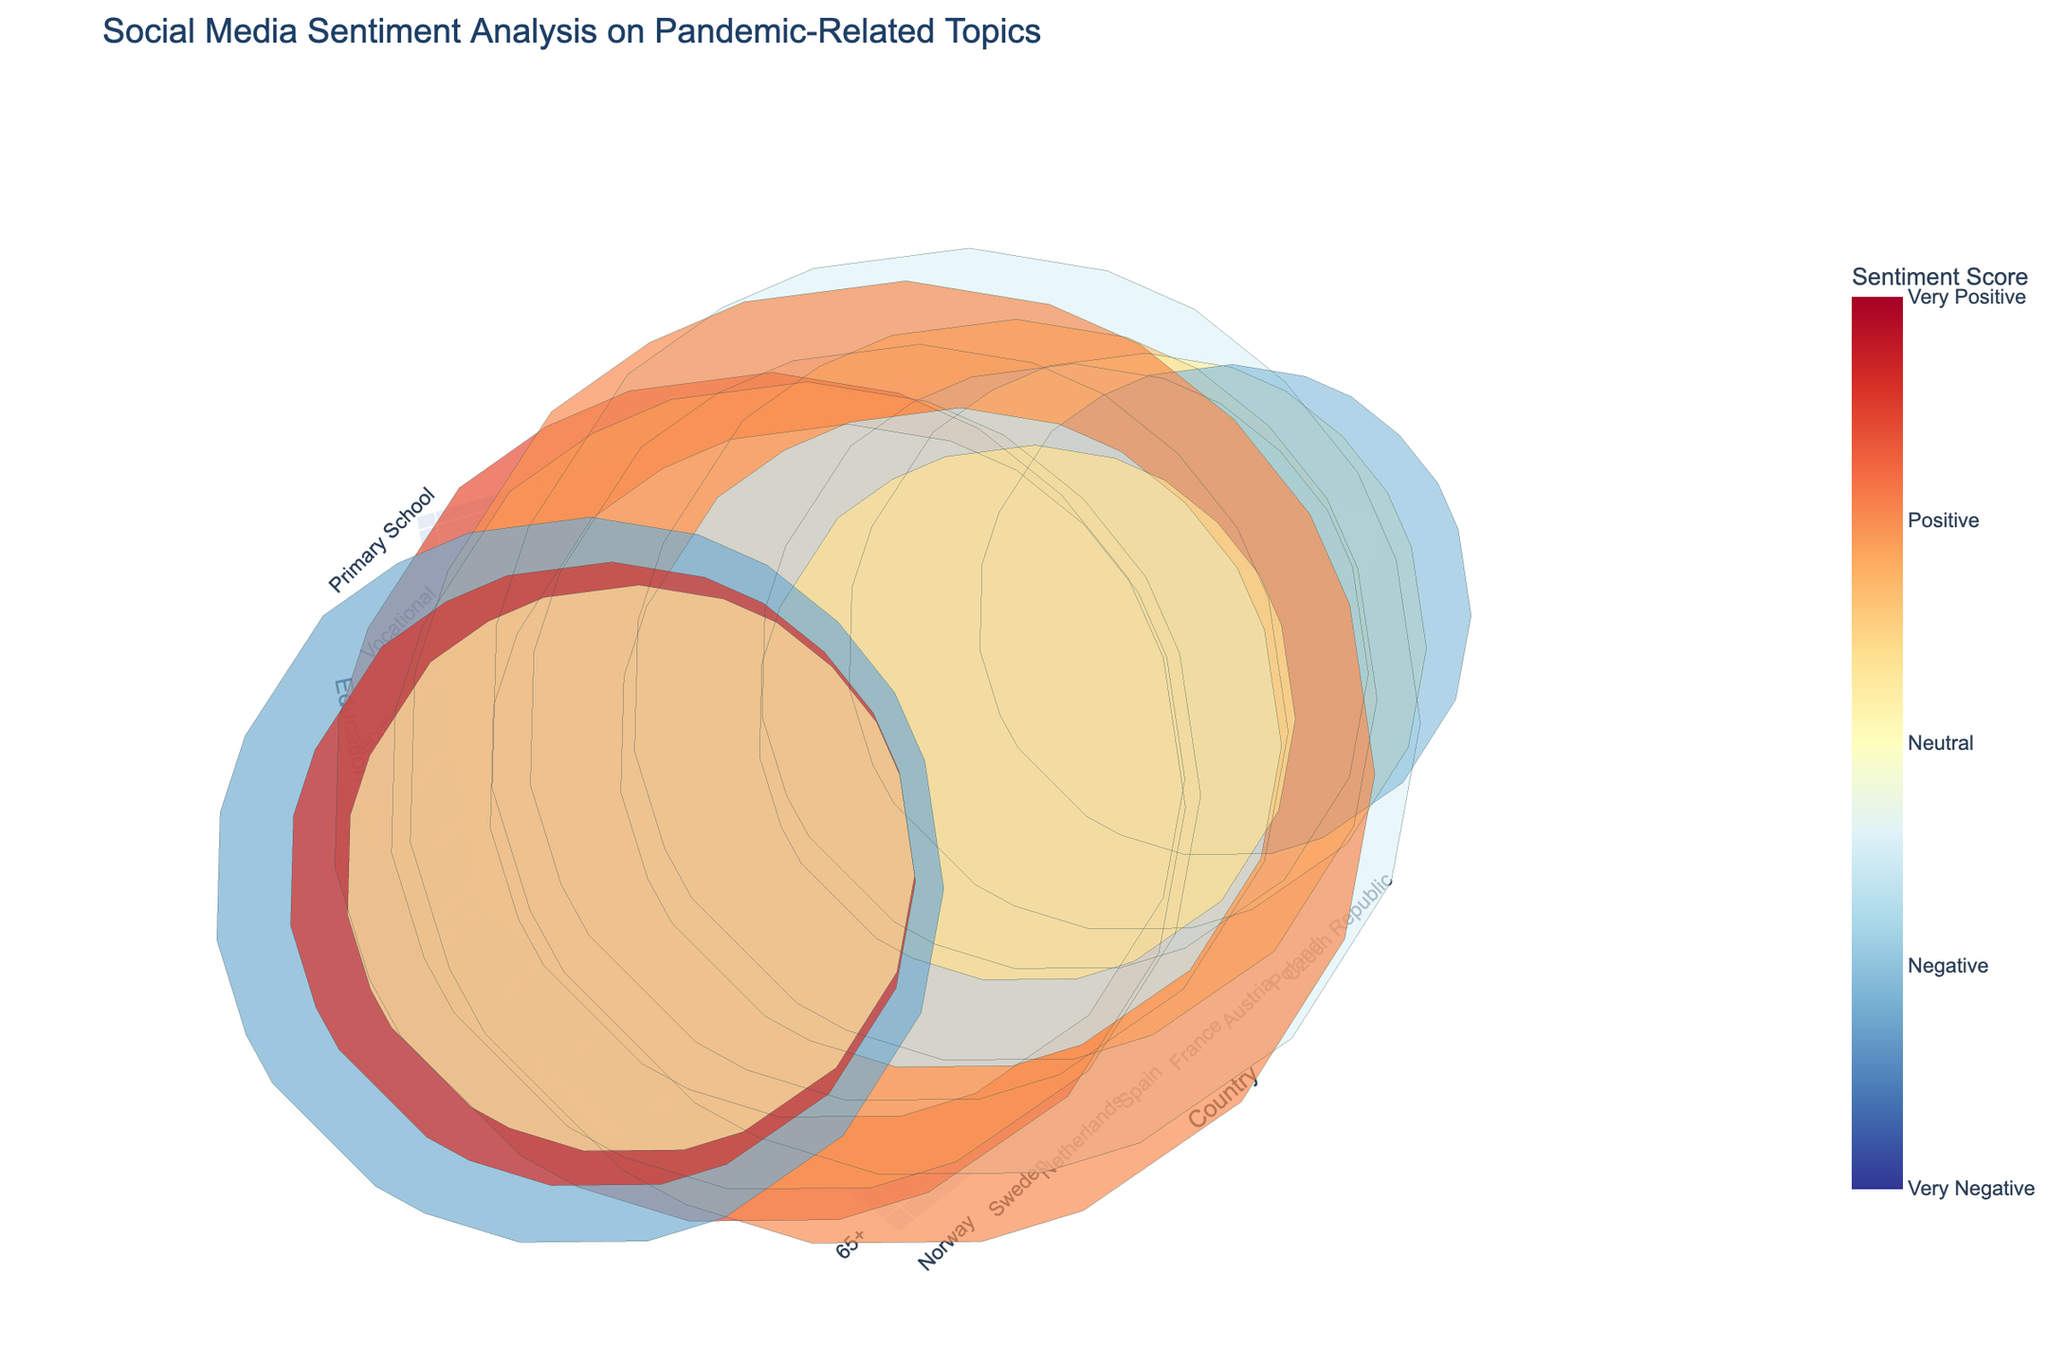What country has the most positive sentiment score? The figure shows the sentiment scores with color coding. Look for the highest (most positive) color on the sentiment scale.
Answer: Denmark What is the title of the figure? The title is displayed at the top of the figure.
Answer: Social Media Sentiment Analysis on Pandemic-Related Topics How many countries are represented in the figure? Count the unique values along the x-axis labeled "Country."
Answer: 14 Which age group has the most negative sentiment towards "Lockdown Measures"? Hover over the bubbles for information on the "Topic." Identify the bubble with the "Topic" labeled "Lockdown Measures" and then look at the "Sentiment Score" and "Age Group" in the hover label.
Answer: 25-34 What topic is associated with the sentiment score of 0.7? Hover over the bubbles to find the "Sentiment Score" of 0.7, and identify the associated "Topic."
Answer: Vaccine Distribution What are the unique education levels displayed in the figure? Look at the z-axis labeled "Education Level" and note the unique categories.
Answer: University, High School, Postgraduate, Secondary School, Vocational, Primary School Which country shows the highest negative sentiment towards "Mask Mandates"? Hover over each bubble to identify "Topic" as "Mask Mandates," then look for the lowest "Sentiment Score" among these bubbles and note the country.
Answer: Hungary Compare the sentiment score for "Remote Learning" and "Social Distancing." What is the difference? Identify the sentiment scores for "Remote Learning" and "Social Distancing" by hovering over their respective bubbles. Subtract the lower score from the higher score.
Answer: 0.1 Which data point has the largest sample size, and what is its sentiment score? Look for the largest bubble size, hover over it to find the "Sample Size" and "Sentiment Score."
Answer: United Kingdom, 0.5 What is the sentiment score of "Mental Health" for the 55-64 age group? Locate the bubble representing the 55-64 age group and hover to find the "Topic" "Mental Health," then note the "Sentiment Score."
Answer: 0.1 